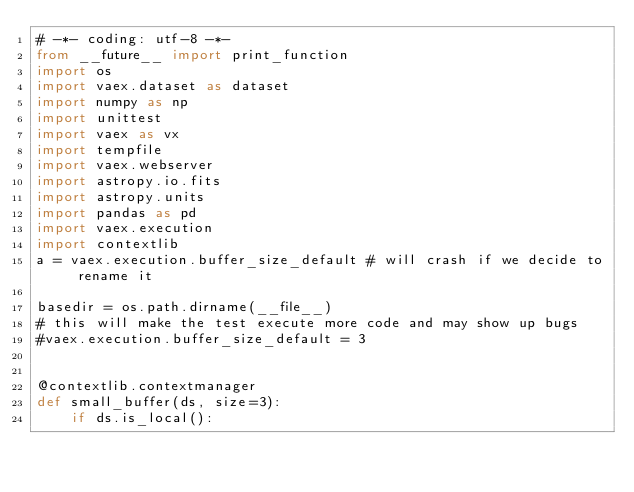Convert code to text. <code><loc_0><loc_0><loc_500><loc_500><_Python_># -*- coding: utf-8 -*-
from __future__ import print_function
import os
import vaex.dataset as dataset
import numpy as np
import unittest
import vaex as vx
import tempfile
import vaex.webserver
import astropy.io.fits
import astropy.units
import pandas as pd
import vaex.execution
import contextlib
a = vaex.execution.buffer_size_default # will crash if we decide to rename it

basedir = os.path.dirname(__file__)
# this will make the test execute more code and may show up bugs
#vaex.execution.buffer_size_default = 3


@contextlib.contextmanager
def small_buffer(ds, size=3):
	if ds.is_local():</code> 